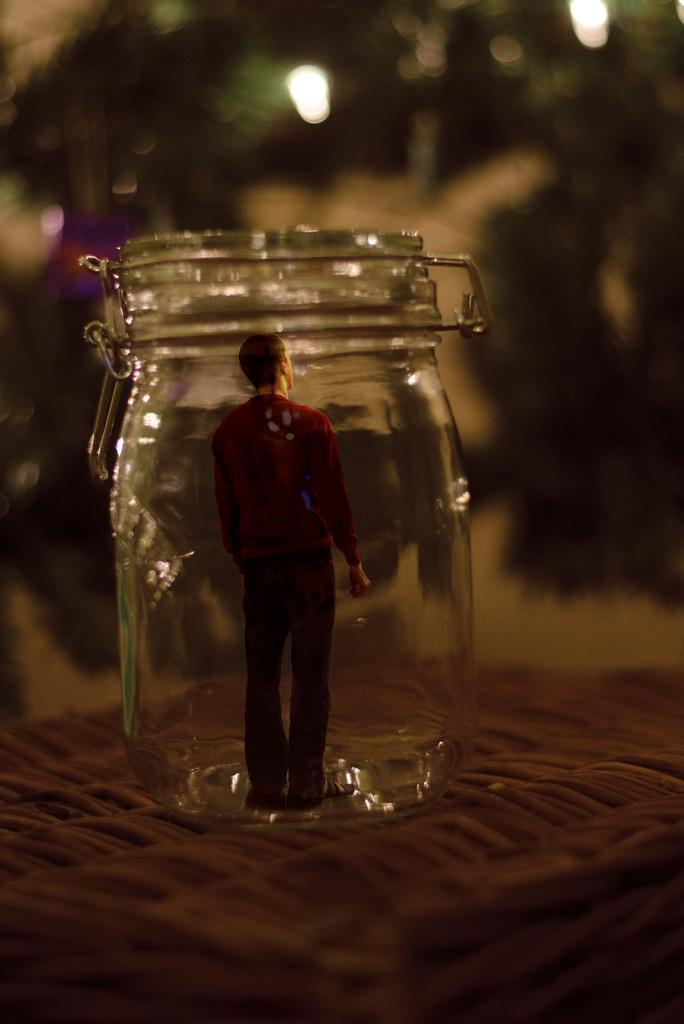What object can be seen in the image? There is a toy in the image. Where is the toy located? The toy is inside a mason jar. Can you describe the background of the image? The background of the image is blurred. How many pigs are guiding the bees in the image? There are no pigs or bees present in the image; it only features a toy inside a mason jar with a blurred background. 